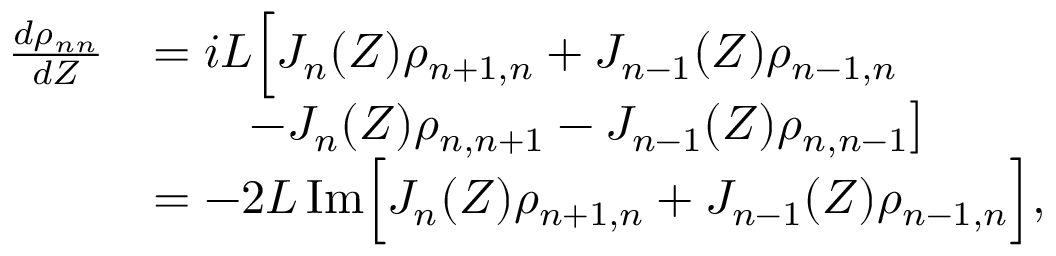Convert formula to latex. <formula><loc_0><loc_0><loc_500><loc_500>\begin{array} { r l } { \frac { d \rho _ { n n } } { d Z } } & { = i L \left [ J _ { n } ( Z ) \rho _ { n + 1 , n } + J _ { n - 1 } ( Z ) \rho _ { n - 1 , n } } \\ & { \quad - J _ { n } ( Z ) \rho _ { n , n + 1 } - J _ { n - 1 } ( Z ) \rho _ { n , n - 1 } \right ] } \\ & { = - 2 L \, I m \left [ J _ { n } ( Z ) \rho _ { n + 1 , n } + J _ { n - 1 } ( Z ) \rho _ { n - 1 , n } \right ] , } \end{array}</formula> 